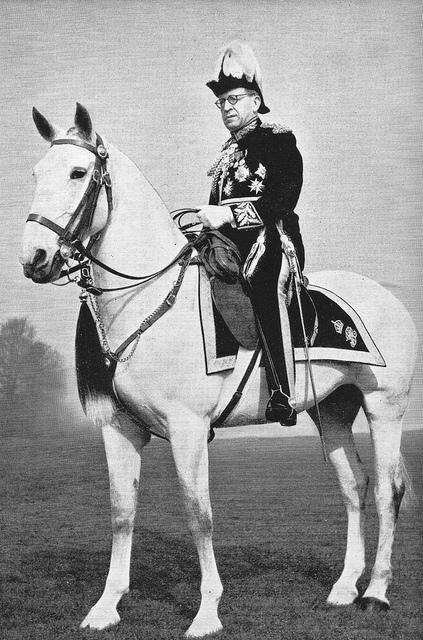Is this a picture taken during the time?
Keep it brief. No. What is the man on?
Concise answer only. Horse. Is this man in the military?
Answer briefly. Yes. 